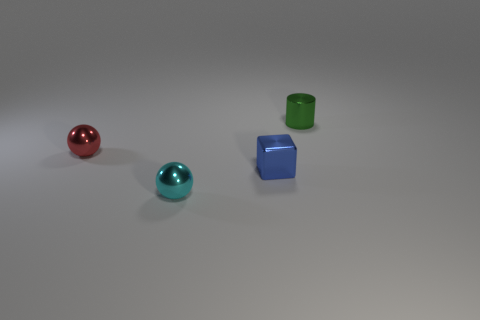Are there fewer tiny red shiny spheres behind the small cyan object than cubes behind the small blue shiny cube?
Give a very brief answer. No. Is the number of big purple metallic objects greater than the number of green metal cylinders?
Your answer should be compact. No. What is the small cyan sphere made of?
Ensure brevity in your answer.  Metal. The small ball behind the cube is what color?
Offer a very short reply. Red. Is the number of green objects that are to the left of the tiny blue shiny block greater than the number of red shiny objects that are behind the tiny green metal object?
Provide a succinct answer. No. There is a sphere in front of the small ball left of the tiny shiny ball that is in front of the red metal sphere; what size is it?
Provide a succinct answer. Small. Are there any tiny rubber spheres that have the same color as the metallic cylinder?
Ensure brevity in your answer.  No. How many tiny blue metallic cubes are there?
Ensure brevity in your answer.  1. What material is the small sphere that is to the right of the metallic thing that is to the left of the small shiny ball that is in front of the tiny red shiny sphere?
Provide a succinct answer. Metal. Is there a tiny cyan sphere that has the same material as the small cylinder?
Offer a very short reply. Yes. 